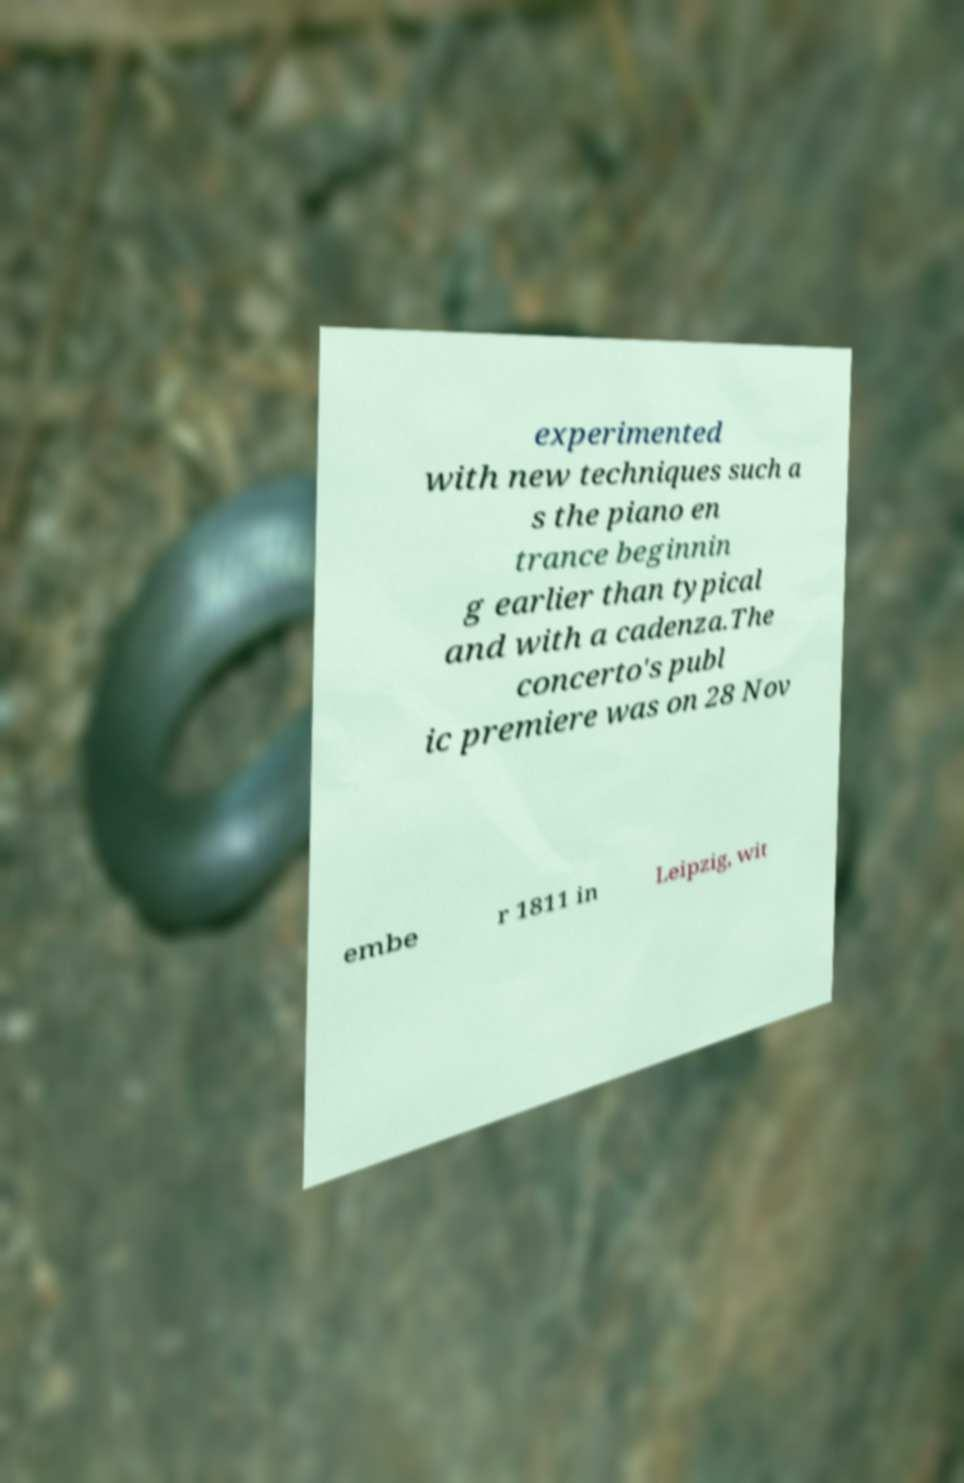I need the written content from this picture converted into text. Can you do that? experimented with new techniques such a s the piano en trance beginnin g earlier than typical and with a cadenza.The concerto's publ ic premiere was on 28 Nov embe r 1811 in Leipzig, wit 